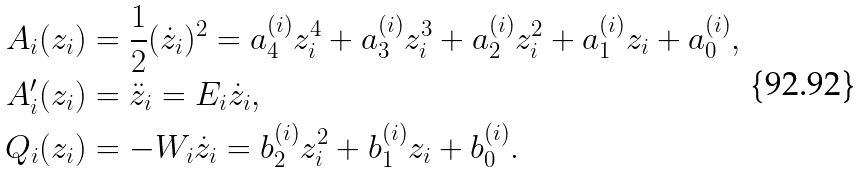<formula> <loc_0><loc_0><loc_500><loc_500>A _ { i } ( z _ { i } ) & = \frac { 1 } { 2 } ( \dot { z } _ { i } ) ^ { 2 } = a _ { 4 } ^ { ( i ) } z _ { i } ^ { 4 } + a _ { 3 } ^ { ( i ) } z _ { i } ^ { 3 } + a _ { 2 } ^ { ( i ) } z _ { i } ^ { 2 } + a _ { 1 } ^ { ( i ) } z _ { i } + a _ { 0 } ^ { ( i ) } , \\ A ^ { \prime } _ { i } ( z _ { i } ) & = \ddot { z } _ { i } = E _ { i } \dot { z } _ { i } , \\ Q _ { i } ( z _ { i } ) & = - W _ { i } \dot { z } _ { i } = b _ { 2 } ^ { ( i ) } z _ { i } ^ { 2 } + b _ { 1 } ^ { ( i ) } z _ { i } + b _ { 0 } ^ { ( i ) } .</formula> 